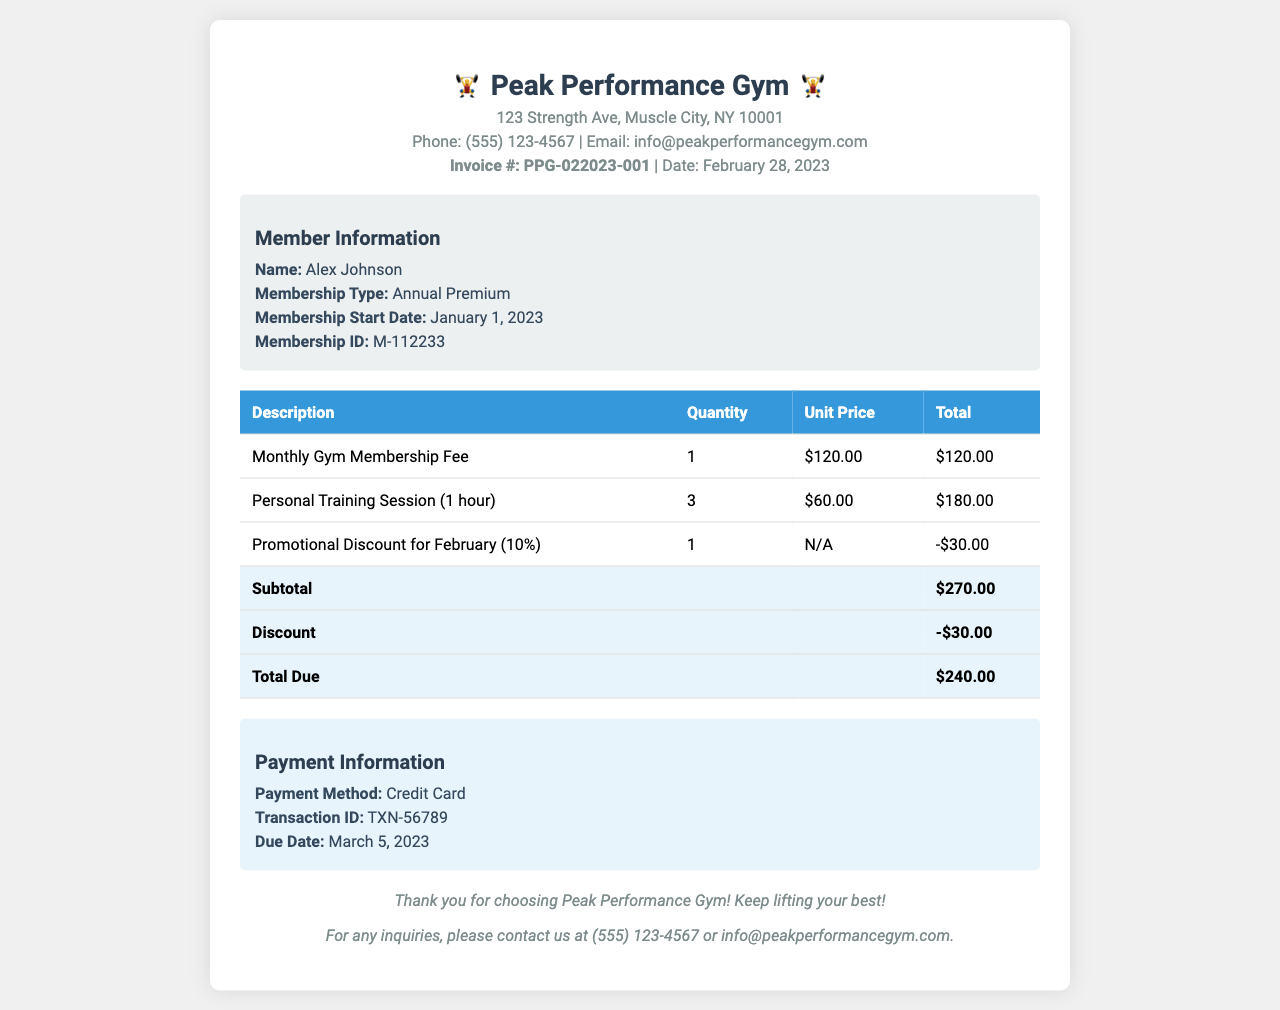What is the invoice number? The invoice number is provided in the document under the invoice information section.
Answer: PPG-022023-001 Who is the member? The member’s name is listed in the member details section of the document.
Answer: Alex Johnson What is the total due amount? The total due amount is calculated in the summary section of the document.
Answer: $240.00 How many personal training sessions were purchased? The quantity of personal training sessions is indicated in the items table.
Answer: 3 What is the membership type? The type of membership is mentioned in the member details section.
Answer: Annual Premium How much was the promotional discount? The amount of the promotional discount is detailed in the items table.
Answer: -$30.00 What is the payment method? The payment method is specified in the payment information section of the document.
Answer: Credit Card When is the payment due date? The due date for payment is located in the payment information section of the document.
Answer: March 5, 2023 What is the subtotal before discount? The subtotal before discount is provided in the total summary of the document.
Answer: $270.00 